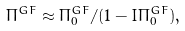Convert formula to latex. <formula><loc_0><loc_0><loc_500><loc_500>\Pi ^ { G F } \approx \Pi _ { 0 } ^ { G F } / ( 1 - I \Pi _ { 0 } ^ { G F } ) ,</formula> 